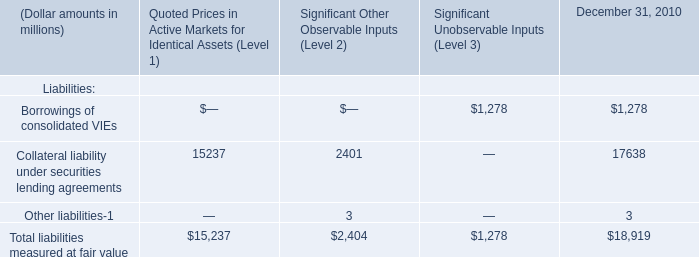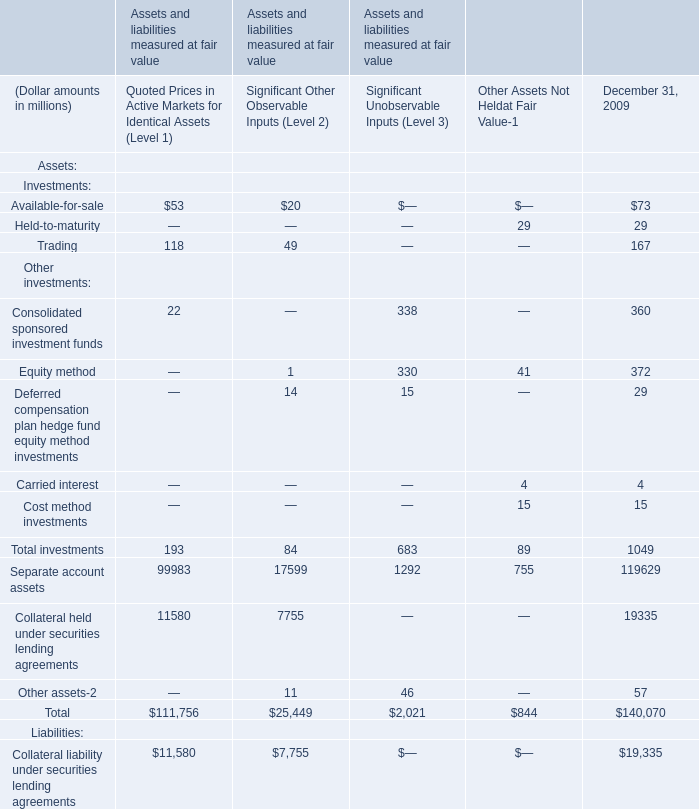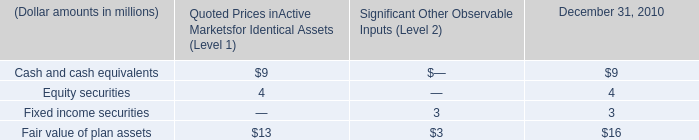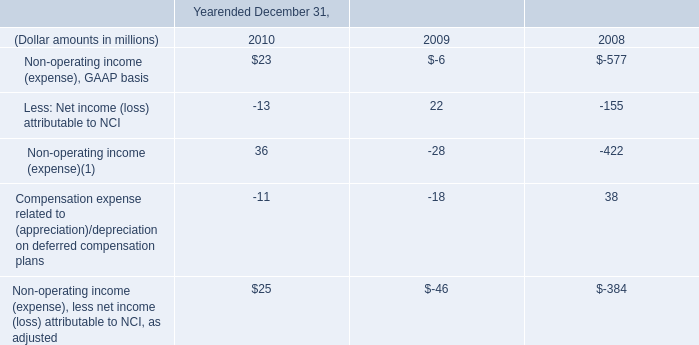What's the sum of Trading in 2009? (in million) 
Answer: 167. 